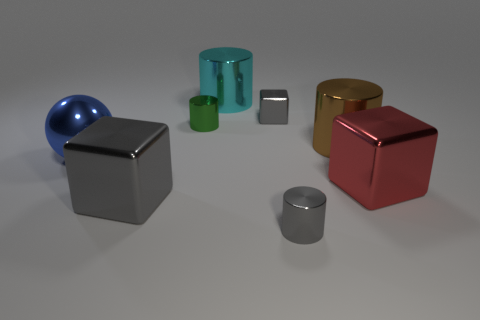Subtract all blue cylinders. How many gray blocks are left? 2 Subtract all tiny green metal cylinders. How many cylinders are left? 3 Subtract all green cylinders. How many cylinders are left? 3 Subtract 2 cylinders. How many cylinders are left? 2 Add 1 tiny green metal objects. How many objects exist? 9 Subtract all purple cylinders. Subtract all blue blocks. How many cylinders are left? 4 Subtract all spheres. How many objects are left? 7 Subtract 0 brown balls. How many objects are left? 8 Subtract all brown metallic objects. Subtract all brown shiny cylinders. How many objects are left? 6 Add 4 red metal objects. How many red metal objects are left? 5 